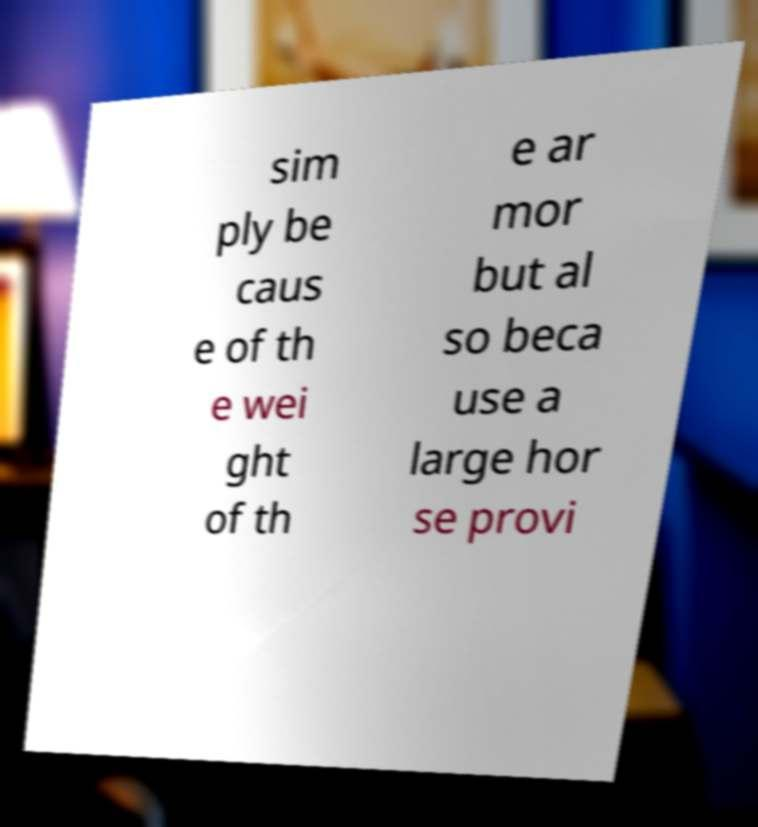Can you read and provide the text displayed in the image?This photo seems to have some interesting text. Can you extract and type it out for me? sim ply be caus e of th e wei ght of th e ar mor but al so beca use a large hor se provi 